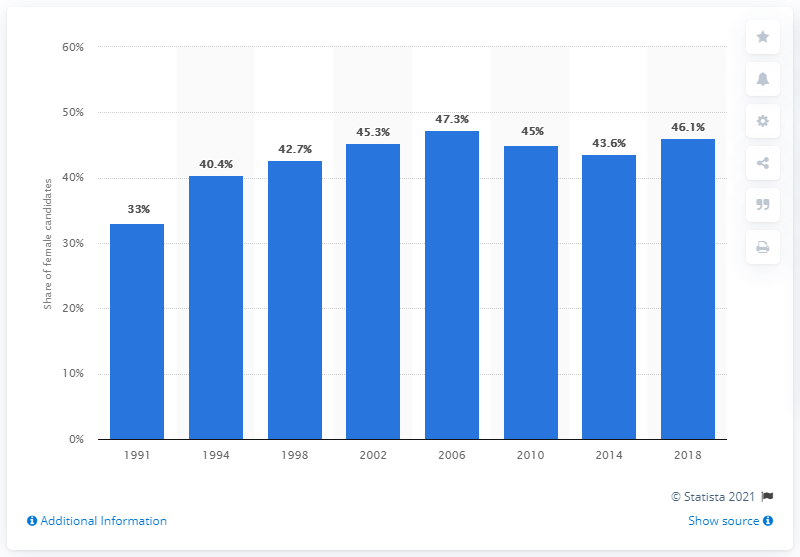Specify some key components in this picture. In 2018, 46.1% of the candidates selected for the Riksdag were female. 